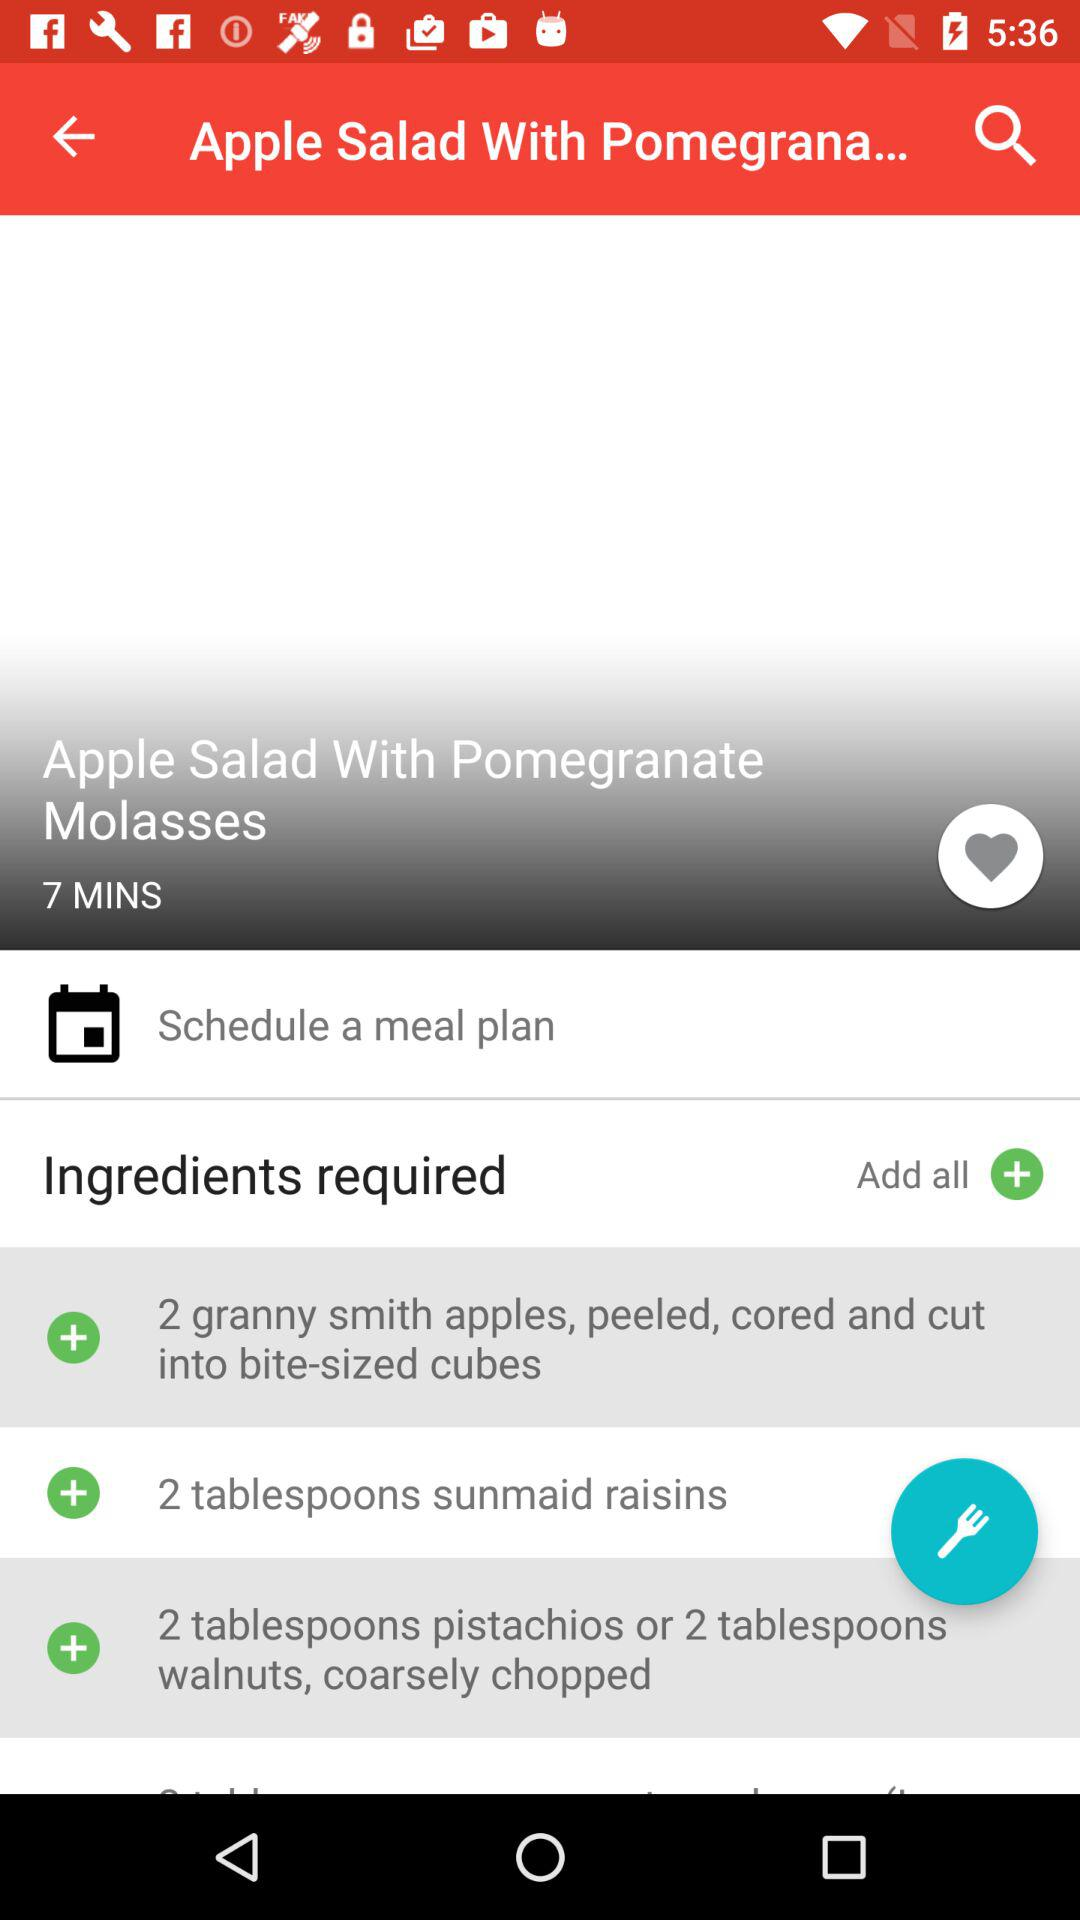What is the duration required to make the meal? The required duration is 7 minutes. 